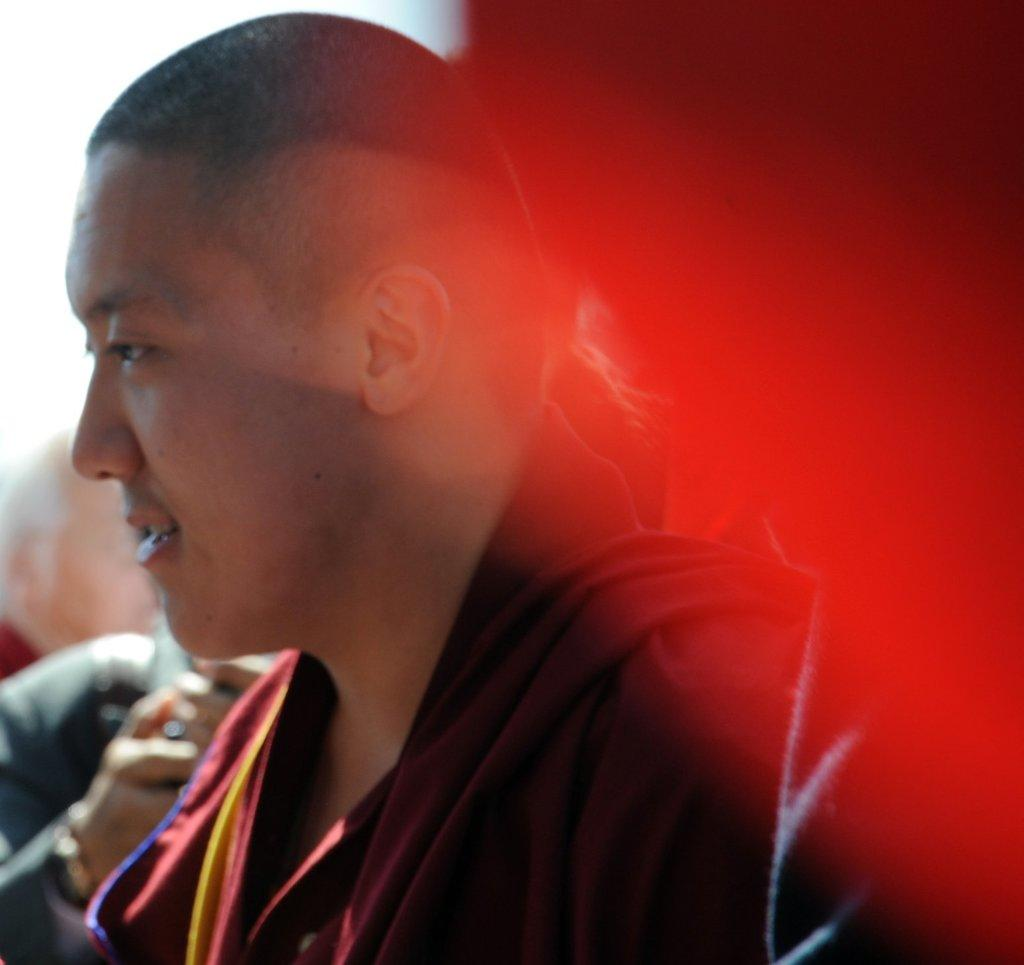Who or what is the main subject of the image? There is a person in the image. Can you describe the surroundings of the person? There are people in the background of the image. What color can be seen on the right side of the image? There is red color on the right side of the image. What type of nerve can be seen in the image? There is no nerve present in the image. Is there a wrench visible in the image? There is no wrench present in the image. 